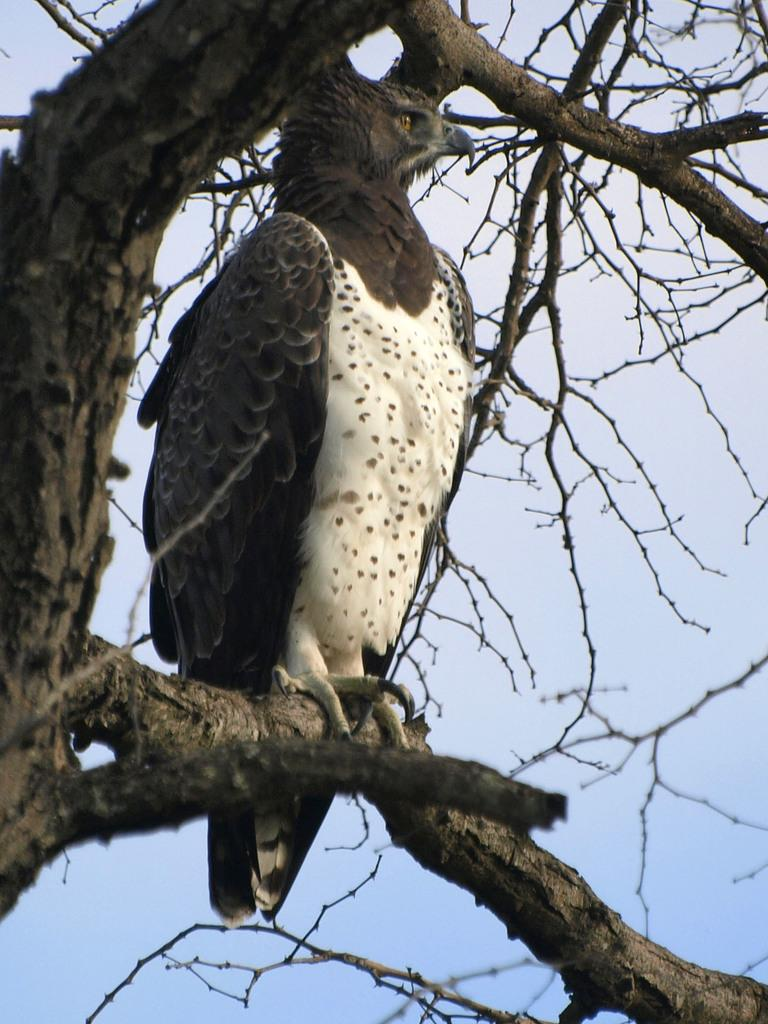What type of animal can be seen in the image? There is a bird in the image. Where is the bird located? The bird is on a tree branch. What can be seen in the background of the image? There is sky visible in the background of the image. What type of cough medicine is the bird taking in the image? There is no cough medicine or indication of a cough in the image; it features a bird on a tree branch with sky visible in the background. 